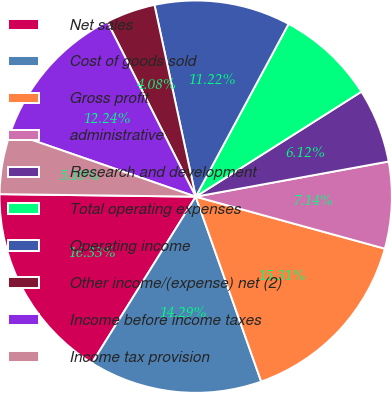<chart> <loc_0><loc_0><loc_500><loc_500><pie_chart><fcel>Net sales<fcel>Cost of goods sold<fcel>Gross profit<fcel>administrative<fcel>Research and development<fcel>Total operating expenses<fcel>Operating income<fcel>Other income/(expense) net (2)<fcel>Income before income taxes<fcel>Income tax provision<nl><fcel>16.33%<fcel>14.29%<fcel>15.31%<fcel>7.14%<fcel>6.12%<fcel>8.16%<fcel>11.22%<fcel>4.08%<fcel>12.24%<fcel>5.1%<nl></chart> 